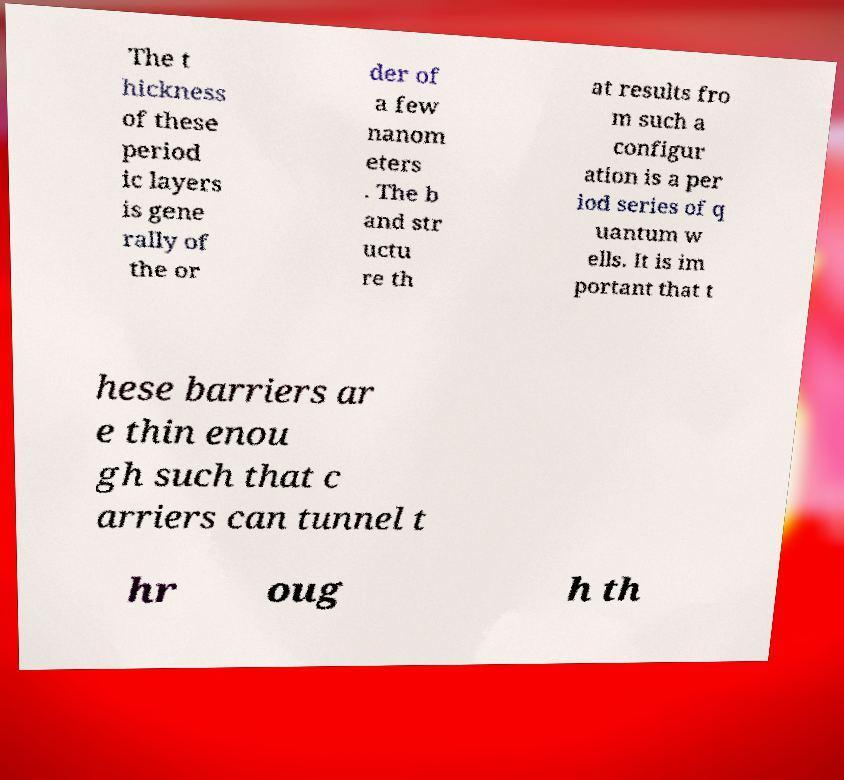For documentation purposes, I need the text within this image transcribed. Could you provide that? The t hickness of these period ic layers is gene rally of the or der of a few nanom eters . The b and str uctu re th at results fro m such a configur ation is a per iod series of q uantum w ells. It is im portant that t hese barriers ar e thin enou gh such that c arriers can tunnel t hr oug h th 